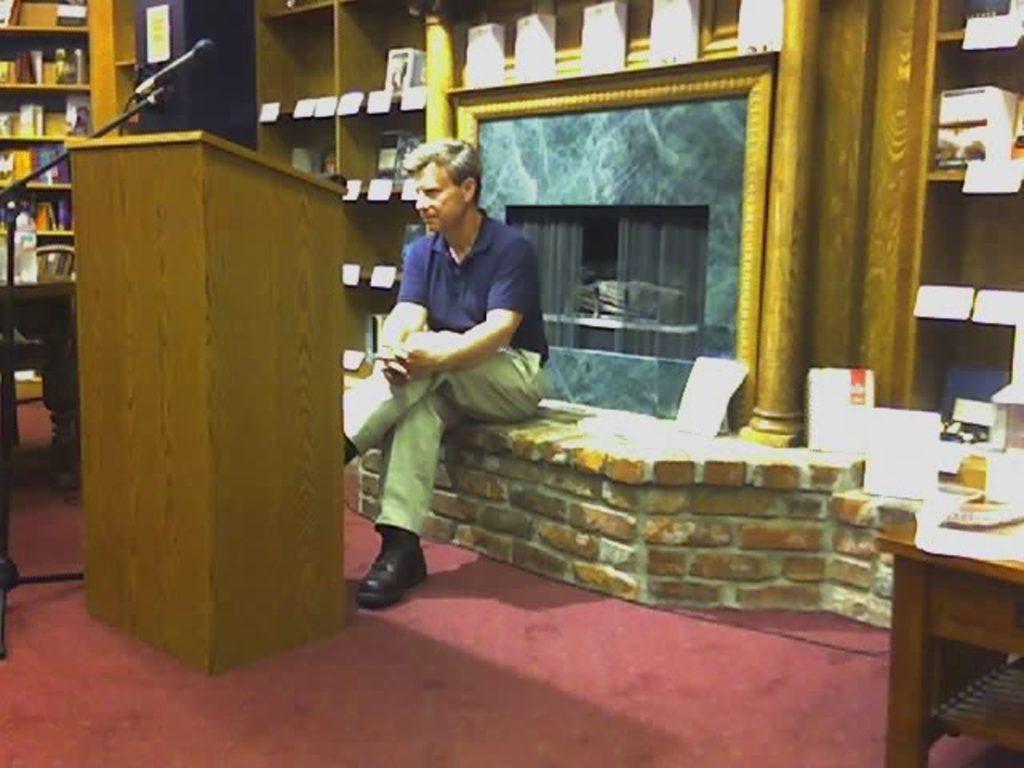Describe this image in one or two sentences. As we can see in the image there are shelves, a man sitting over here. He is wearing blue color shirt, black color shoes. On the right side there is a table. On table there is a plate. On the left side there is a mic. 